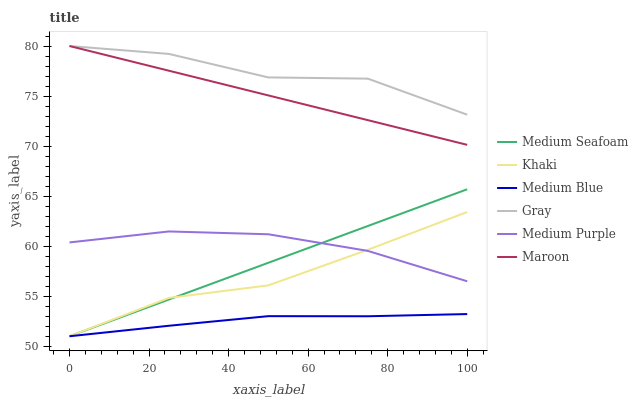Does Medium Blue have the minimum area under the curve?
Answer yes or no. Yes. Does Gray have the maximum area under the curve?
Answer yes or no. Yes. Does Khaki have the minimum area under the curve?
Answer yes or no. No. Does Khaki have the maximum area under the curve?
Answer yes or no. No. Is Maroon the smoothest?
Answer yes or no. Yes. Is Gray the roughest?
Answer yes or no. Yes. Is Khaki the smoothest?
Answer yes or no. No. Is Khaki the roughest?
Answer yes or no. No. Does Khaki have the lowest value?
Answer yes or no. Yes. Does Maroon have the lowest value?
Answer yes or no. No. Does Maroon have the highest value?
Answer yes or no. Yes. Does Khaki have the highest value?
Answer yes or no. No. Is Medium Purple less than Maroon?
Answer yes or no. Yes. Is Gray greater than Medium Seafoam?
Answer yes or no. Yes. Does Medium Purple intersect Medium Seafoam?
Answer yes or no. Yes. Is Medium Purple less than Medium Seafoam?
Answer yes or no. No. Is Medium Purple greater than Medium Seafoam?
Answer yes or no. No. Does Medium Purple intersect Maroon?
Answer yes or no. No. 